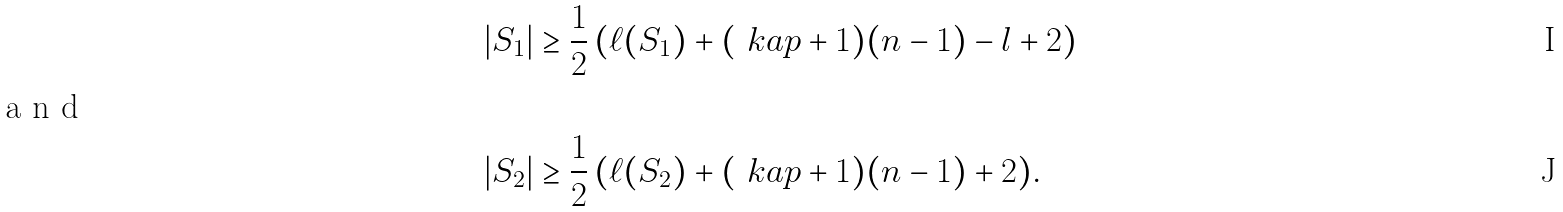<formula> <loc_0><loc_0><loc_500><loc_500>| S _ { 1 } | & \geq \frac { 1 } { 2 } \, ( \ell ( S _ { 1 } ) + ( \ k a p + 1 ) ( n - 1 ) - l + 2 ) \\ \intertext { a n d } | S _ { 2 } | & \geq \frac { 1 } { 2 } \, ( \ell ( S _ { 2 } ) + ( \ k a p + 1 ) ( n - 1 ) + 2 ) .</formula> 